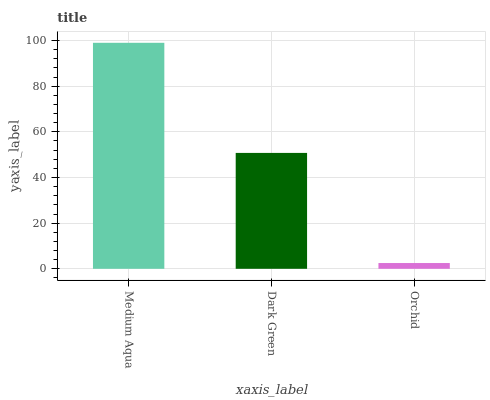Is Orchid the minimum?
Answer yes or no. Yes. Is Medium Aqua the maximum?
Answer yes or no. Yes. Is Dark Green the minimum?
Answer yes or no. No. Is Dark Green the maximum?
Answer yes or no. No. Is Medium Aqua greater than Dark Green?
Answer yes or no. Yes. Is Dark Green less than Medium Aqua?
Answer yes or no. Yes. Is Dark Green greater than Medium Aqua?
Answer yes or no. No. Is Medium Aqua less than Dark Green?
Answer yes or no. No. Is Dark Green the high median?
Answer yes or no. Yes. Is Dark Green the low median?
Answer yes or no. Yes. Is Medium Aqua the high median?
Answer yes or no. No. Is Orchid the low median?
Answer yes or no. No. 